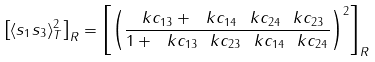Convert formula to latex. <formula><loc_0><loc_0><loc_500><loc_500>\left [ \langle s _ { 1 } s _ { 3 } \rangle ^ { 2 } _ { T } \right ] _ { R } = \left [ \left ( \frac { \ k c _ { 1 3 } + \ k c _ { 1 4 } \ k c _ { 2 4 } \ k c _ { 2 3 } } { 1 + \ k c _ { 1 3 } \ k c _ { 2 3 } \ k c _ { 1 4 } \ k c _ { 2 4 } } \right ) ^ { 2 } \right ] _ { R }</formula> 